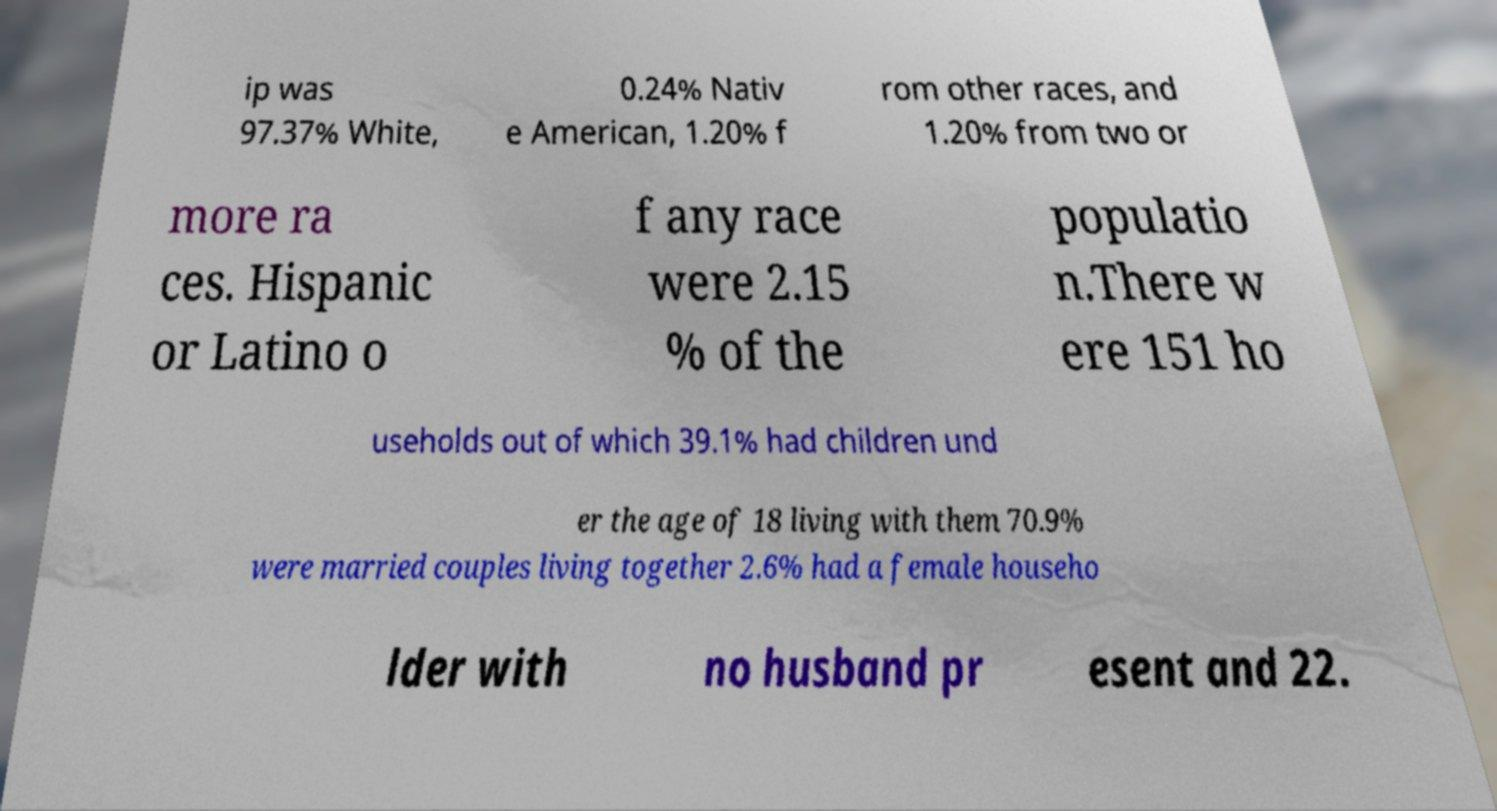There's text embedded in this image that I need extracted. Can you transcribe it verbatim? ip was 97.37% White, 0.24% Nativ e American, 1.20% f rom other races, and 1.20% from two or more ra ces. Hispanic or Latino o f any race were 2.15 % of the populatio n.There w ere 151 ho useholds out of which 39.1% had children und er the age of 18 living with them 70.9% were married couples living together 2.6% had a female househo lder with no husband pr esent and 22. 